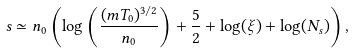<formula> <loc_0><loc_0><loc_500><loc_500>s \simeq n _ { 0 } \left ( \log \left ( \frac { ( m T _ { 0 } ) ^ { 3 / 2 } } { n _ { 0 } } \right ) + \frac { 5 } { 2 } + \log ( \xi ) + \log ( N _ { s } ) \right ) ,</formula> 